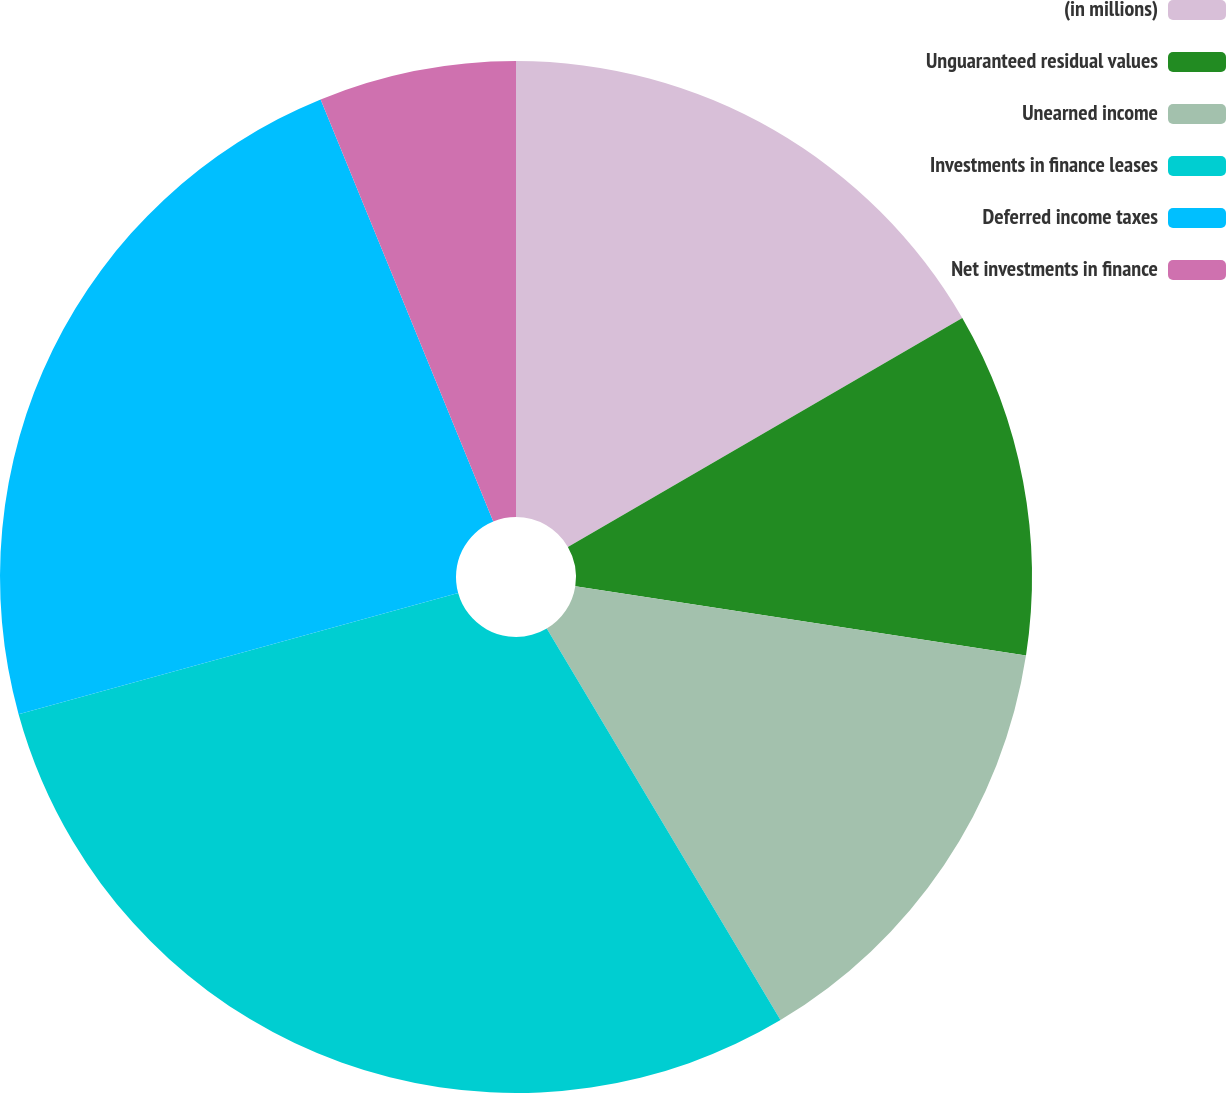<chart> <loc_0><loc_0><loc_500><loc_500><pie_chart><fcel>(in millions)<fcel>Unguaranteed residual values<fcel>Unearned income<fcel>Investments in finance leases<fcel>Deferred income taxes<fcel>Net investments in finance<nl><fcel>16.63%<fcel>10.8%<fcel>14.0%<fcel>29.28%<fcel>23.1%<fcel>6.18%<nl></chart> 